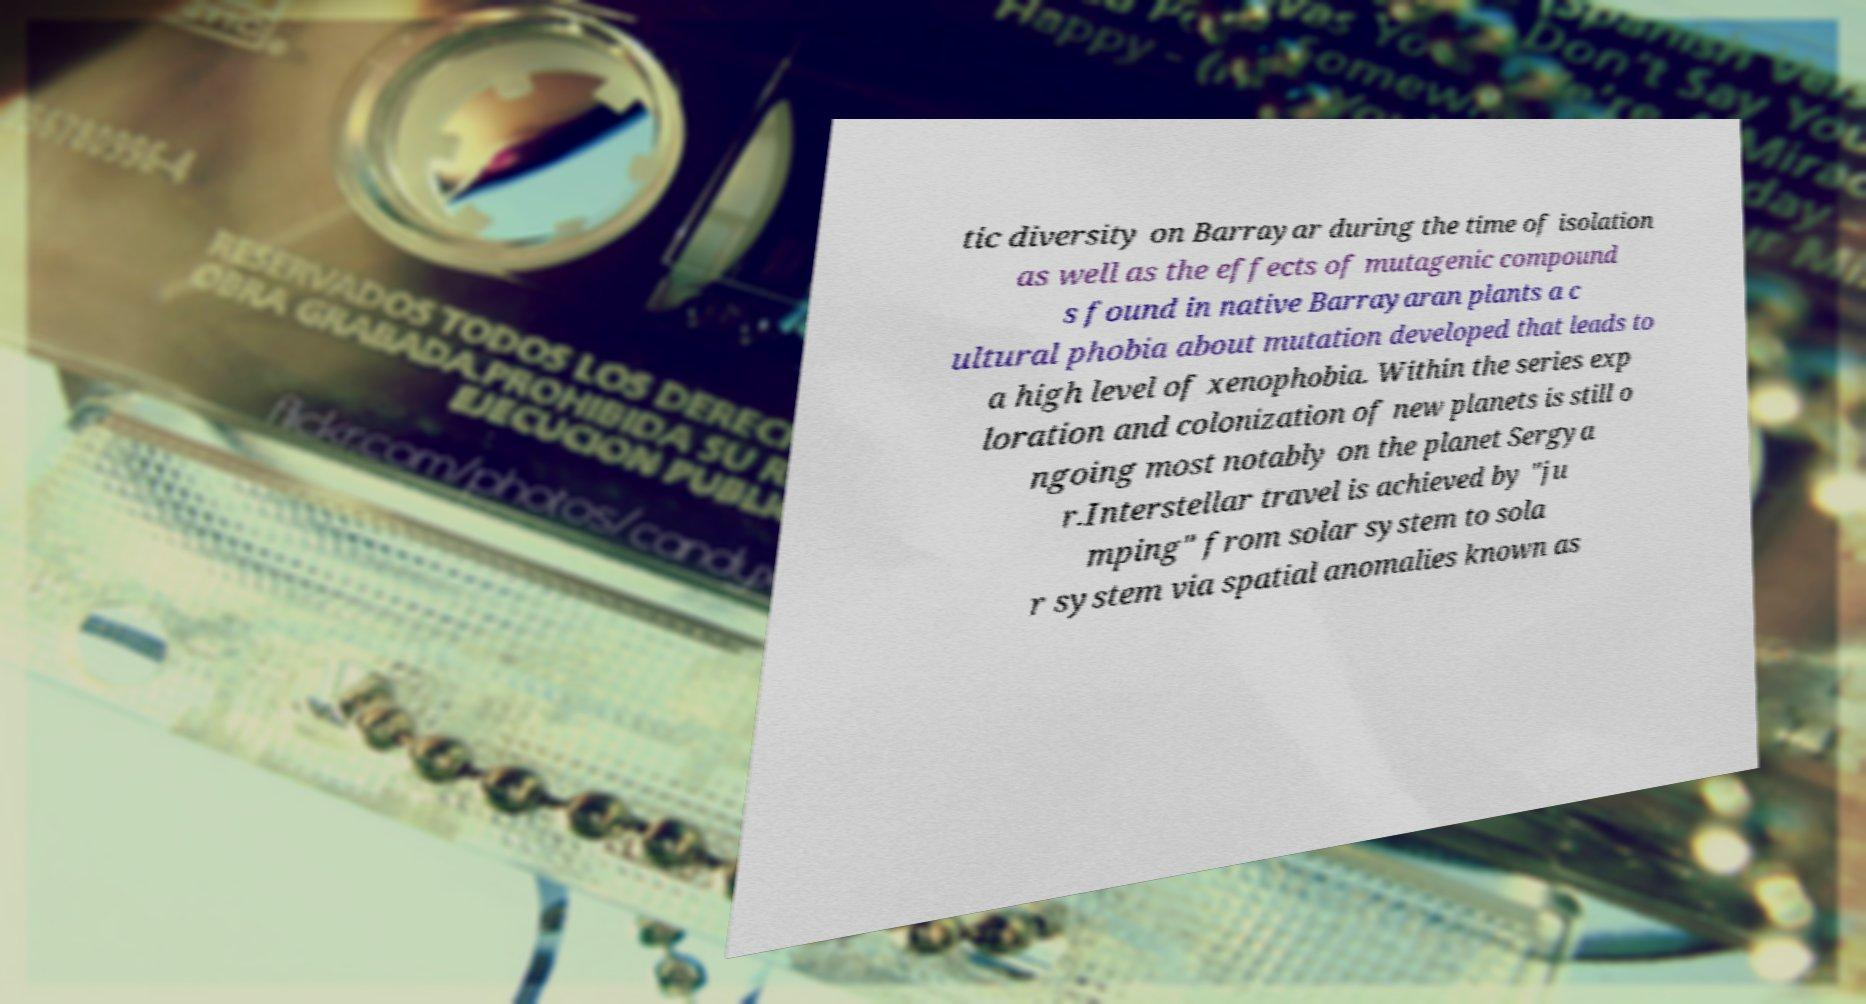Please read and relay the text visible in this image. What does it say? tic diversity on Barrayar during the time of isolation as well as the effects of mutagenic compound s found in native Barrayaran plants a c ultural phobia about mutation developed that leads to a high level of xenophobia. Within the series exp loration and colonization of new planets is still o ngoing most notably on the planet Sergya r.Interstellar travel is achieved by "ju mping" from solar system to sola r system via spatial anomalies known as 